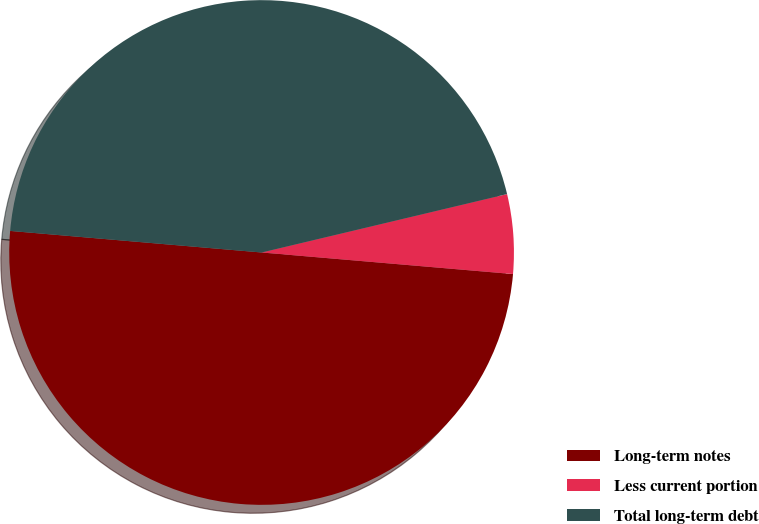Convert chart to OTSL. <chart><loc_0><loc_0><loc_500><loc_500><pie_chart><fcel>Long-term notes<fcel>Less current portion<fcel>Total long-term debt<nl><fcel>50.0%<fcel>5.08%<fcel>44.92%<nl></chart> 